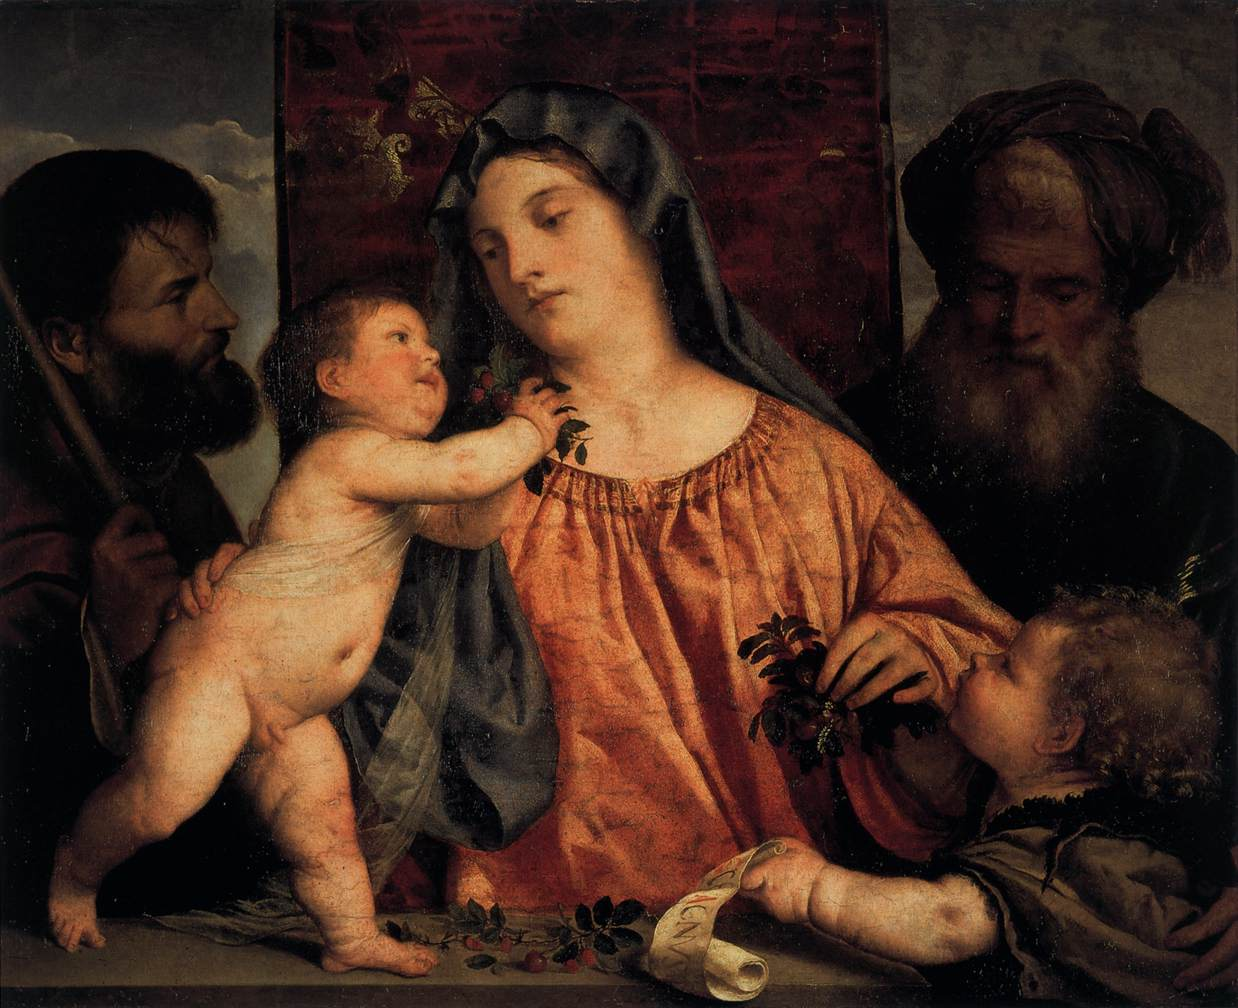How does the artwork reflect the religious beliefs of the time? The painting embodies the sacred themes central to Renaissance religious beliefs. It emphasizes the importance of the Holy Family in Christian iconography, with Mary and Jesus as the focal points. The portrayal of the figures with gentle expressions and the intimate interaction among them serves not only as a reminder of their holy significance but also imbues them with a humane aspect that would have resonated deeply with the faithful of the time. 